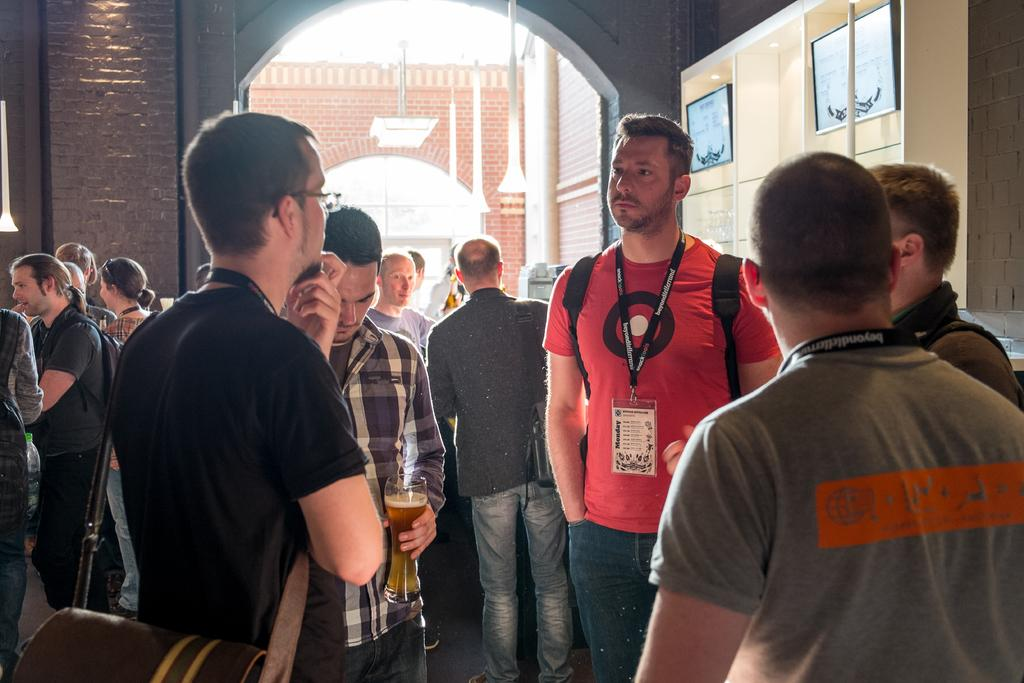How many people are in the image? There is a group of persons in the image. What are some of the persons doing in the image? Some of the persons are carrying bags on their backs. What can be seen in the background of the image? There is a wall in the background of the image. What type of jewel is being exchanged between the persons in the image? There is no indication of a jewel or any exchange taking place in the image. How many seats are visible in the image? There is no mention of seats in the image; it features a group of persons and a wall in the background. 